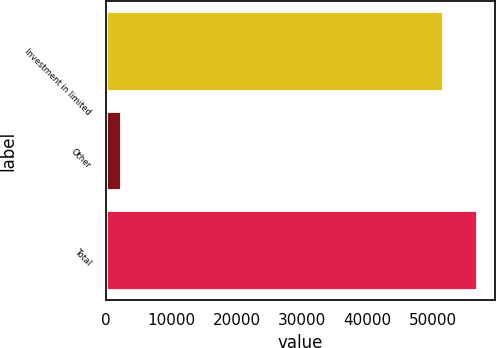Convert chart. <chart><loc_0><loc_0><loc_500><loc_500><bar_chart><fcel>Investment in limited<fcel>Other<fcel>Total<nl><fcel>51509<fcel>2343<fcel>56659.9<nl></chart> 